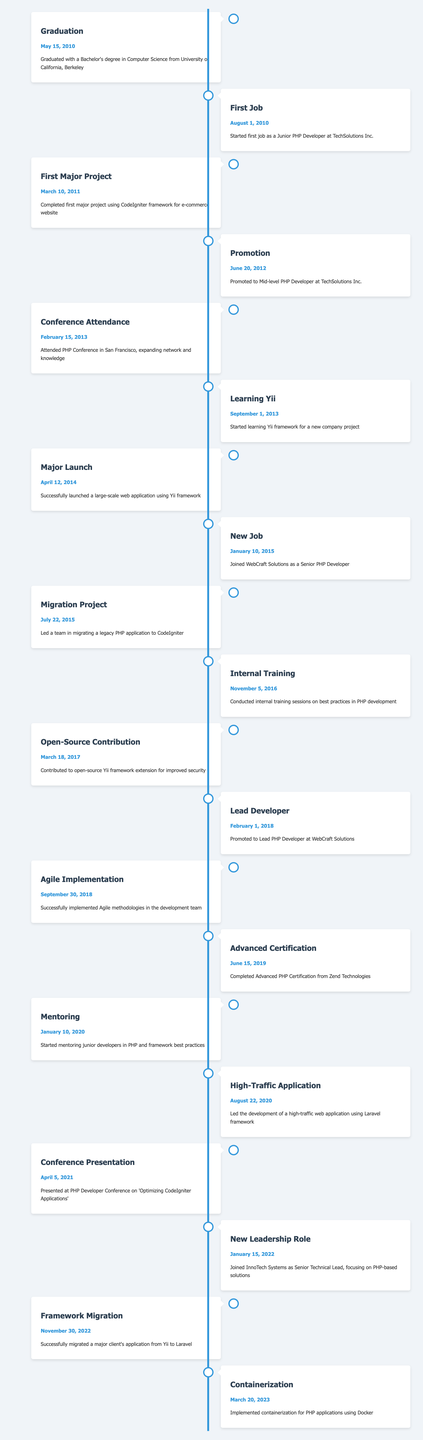What date did you graduate with a Bachelor's degree in Computer Science? The event related to graduation is listed in the timeline table as occurring on May 15, 2010.
Answer: May 15, 2010 How long did you work at TechSolutions Inc. before being promoted? You started as a Junior PHP Developer on August 1, 2010, and were promoted to Mid-level PHP Developer on June 20, 2012. This indicates a period of 1 year and 10 months at the company before promotion.
Answer: 1 year and 10 months Is there a specific event related to the Yii framework in your career timeline? Yes, the timeline mentions starting to learn the Yii framework on September 1, 2013, and successfully launching a large-scale web application using it on April 12, 2014, which indicates a focus on this framework.
Answer: Yes Count the total number of promotions mentioned in the timeline. The promotions listed are: from Junior to Mid-level (June 20, 2012), then to Lead PHP Developer (February 1, 2018). Summing these gives a total of 2 promotions.
Answer: 2 Which year did you join WebCraft Solutions? You joined WebCraft Solutions as a Senior PHP Developer on January 10, 2015, so the year is 2015.
Answer: 2015 What were the major frameworks you worked with as mentioned in the timeline? The timelines mention major frameworks: CodeIgniter (first major project in 2011), Yii (launched application in 2014), and Laravel (development of high-traffic application in 2020). This indicates experience with three different frameworks.
Answer: CodeIgniter, Yii, Laravel Did you attend any conferences during your career, and if so, when? Yes, you attended a PHP Conference in San Francisco on February 15, 2013.
Answer: Yes, February 15, 2013 What was the last milestone event recorded in your career timeline? The last event recorded was on March 20, 2023, which involved implementing containerization for PHP applications using Docker.
Answer: March 20, 2023 How many years passed between your graduation and your first major project completion? You graduated on May 15, 2010, and completed your first major project using CodeIgniter on March 10, 2011. This is a period of approximately 9 months.
Answer: 9 months 